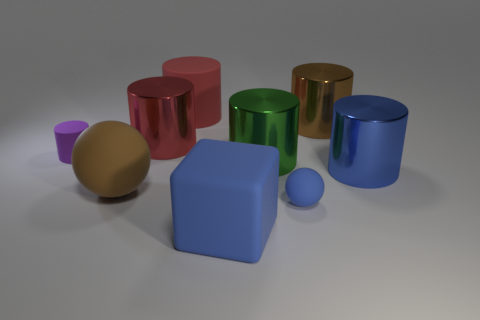There is a thing that is behind the brown shiny cylinder; is it the same size as the big green metallic object?
Your answer should be very brief. Yes. There is a metal cylinder that is the same color as the small rubber ball; what is its size?
Your answer should be compact. Large. Is there a purple thing of the same size as the green object?
Offer a terse response. No. Does the matte cylinder to the right of the small rubber cylinder have the same color as the metallic cylinder that is in front of the green object?
Offer a terse response. No. Are there any big metal things of the same color as the tiny ball?
Your response must be concise. Yes. How many other things are the same shape as the red metallic thing?
Make the answer very short. 5. What is the shape of the large brown thing behind the large brown ball?
Offer a very short reply. Cylinder. Do the large brown metallic object and the small rubber thing that is to the right of the large red rubber cylinder have the same shape?
Offer a terse response. No. What is the size of the object that is both behind the tiny matte cylinder and to the right of the red rubber object?
Your answer should be compact. Large. What is the color of the rubber object that is both on the left side of the big blue block and in front of the purple object?
Your response must be concise. Brown. 